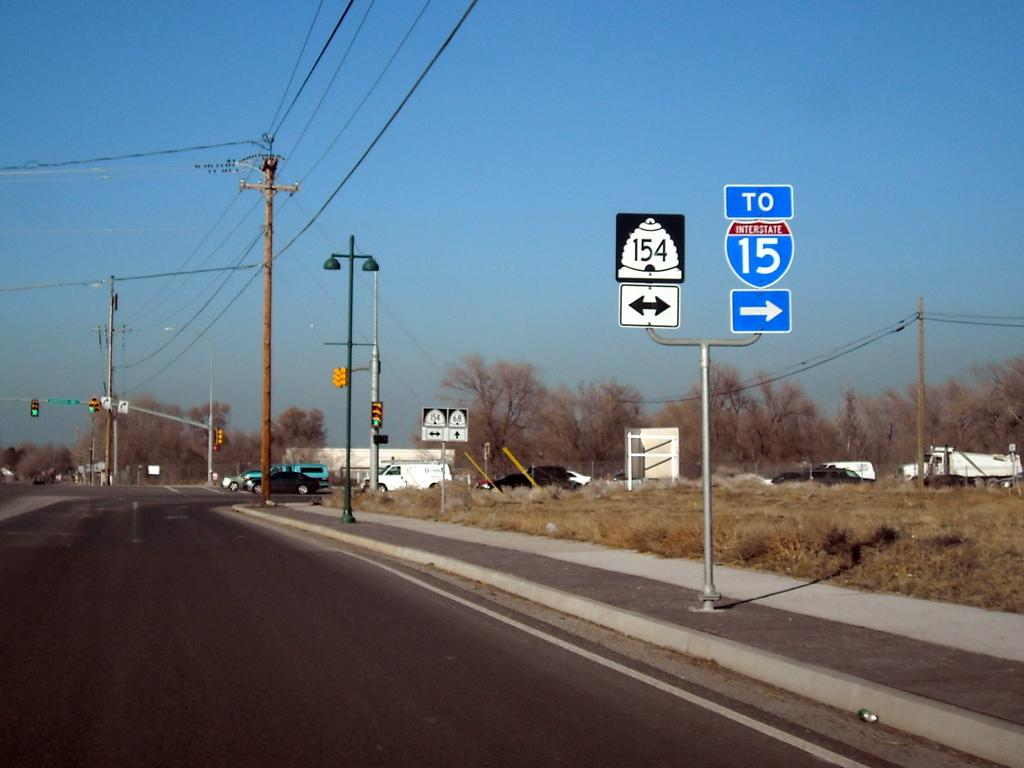<image>
Share a concise interpretation of the image provided. A sign shows drivers that they need to turn right to get onto highway 15. 